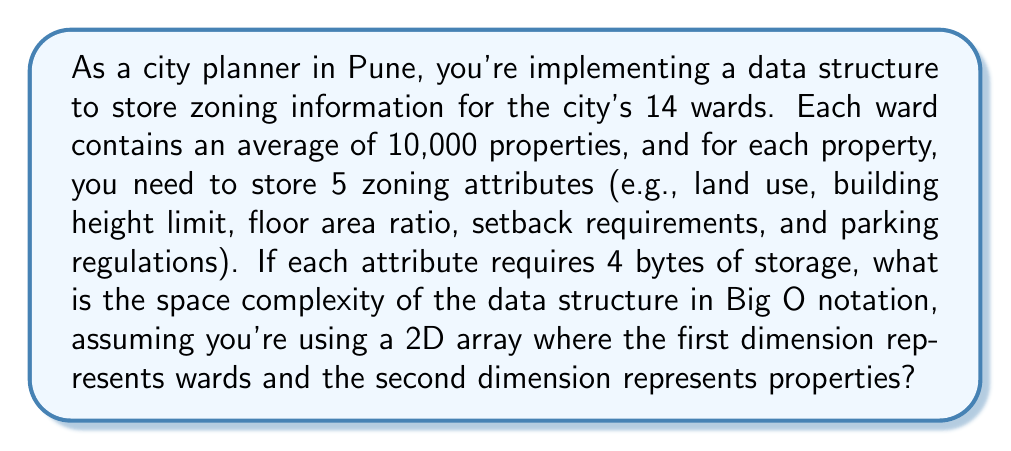What is the answer to this math problem? To calculate the space complexity, let's break down the problem:

1. Number of wards: 14
2. Average number of properties per ward: 10,000
3. Number of zoning attributes per property: 5
4. Storage required for each attribute: 4 bytes

Let's analyze the space requirements:

1. The 2D array structure:
   - First dimension (wards): 14
   - Second dimension (properties): 10,000

2. For each property, we store 5 attributes, each taking 4 bytes:
   $$ \text{Space per property} = 5 \times 4 = 20 \text{ bytes} $$

3. Total space required:
   $$ \text{Total space} = 14 \times 10,000 \times 20 = 2,800,000 \text{ bytes} $$

In Big O notation, we're interested in how the space requirements grow with the input size. Let's define variables:

- $w$: number of wards
- $p$: number of properties per ward
- $a$: number of attributes per property
- $b$: bytes per attribute

The general formula for space complexity would be:
$$ O(w \times p \times a \times b) $$

However, in Big O notation, we typically ignore constant factors and lower-order terms. The number of attributes ($a$) and bytes per attribute ($b$) are constants in this scenario.

Therefore, the space complexity simplifies to:
$$ O(w \times p) $$

This represents a 2D array where the size grows linearly with both the number of wards and the number of properties per ward.
Answer: $O(w \times p)$, where $w$ is the number of wards and $p$ is the number of properties per ward. 